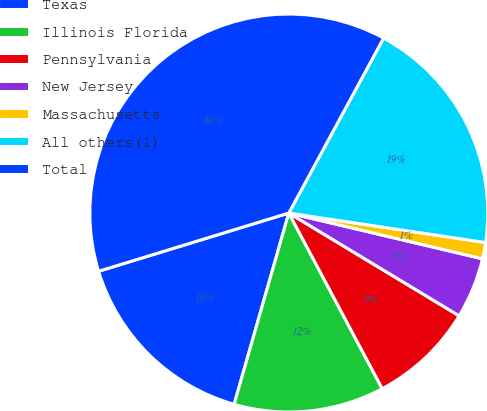Convert chart. <chart><loc_0><loc_0><loc_500><loc_500><pie_chart><fcel>Texas<fcel>Illinois Florida<fcel>Pennsylvania<fcel>New Jersey<fcel>Massachusetts<fcel>All others(1)<fcel>Total<nl><fcel>15.84%<fcel>12.21%<fcel>8.58%<fcel>4.95%<fcel>1.32%<fcel>19.47%<fcel>37.63%<nl></chart> 